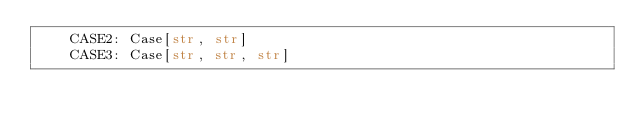<code> <loc_0><loc_0><loc_500><loc_500><_Python_>    CASE2: Case[str, str]
    CASE3: Case[str, str, str]
</code> 